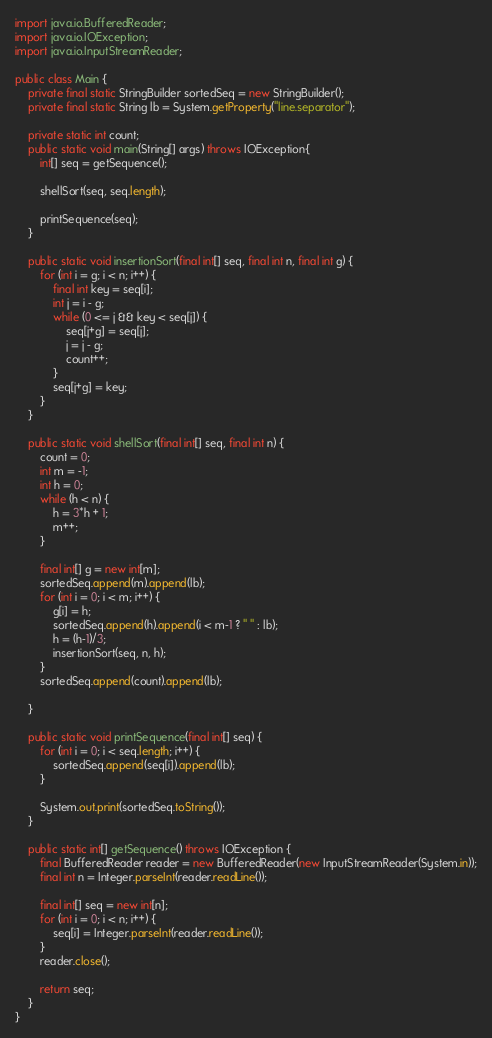<code> <loc_0><loc_0><loc_500><loc_500><_Java_>import java.io.BufferedReader;
import java.io.IOException;
import java.io.InputStreamReader;

public class Main {
	private final static StringBuilder sortedSeq = new StringBuilder();
	private final static String lb = System.getProperty("line.separator");
	
	private static int count;
	public static void main(String[] args) throws IOException{
		int[] seq = getSequence();
		
		shellSort(seq, seq.length);
		
		printSequence(seq);
	}
	
	public static void insertionSort(final int[] seq, final int n, final int g) {
		for (int i = g; i < n; i++) {
			final int key = seq[i];
			int j = i - g;
			while (0 <= j && key < seq[j]) {
				seq[j+g] = seq[j];
				j = j - g;
				count++;
			}
			seq[j+g] = key;
		}
	}
	
	public static void shellSort(final int[] seq, final int n) {
		count = 0;
		int m = -1;
		int h = 0;
		while (h < n) {
			h = 3*h + 1;
			m++;
		}
		
		final int[] g = new int[m];
		sortedSeq.append(m).append(lb);
		for (int i = 0; i < m; i++) {
			g[i] = h;
			sortedSeq.append(h).append(i < m-1 ? " " : lb);
			h = (h-1)/3;
			insertionSort(seq, n, h);
		}
		sortedSeq.append(count).append(lb);
		
	}
	
	public static void printSequence(final int[] seq) {
		for (int i = 0; i < seq.length; i++) {
			sortedSeq.append(seq[i]).append(lb);
		}
		
		System.out.print(sortedSeq.toString());
	}
	
	public static int[] getSequence() throws IOException {
		final BufferedReader reader = new BufferedReader(new InputStreamReader(System.in));
		final int n = Integer.parseInt(reader.readLine());
		
		final int[] seq = new int[n];
		for (int i = 0; i < n; i++) {
			seq[i] = Integer.parseInt(reader.readLine());
		}
		reader.close();
		
		return seq;
	}
}</code> 